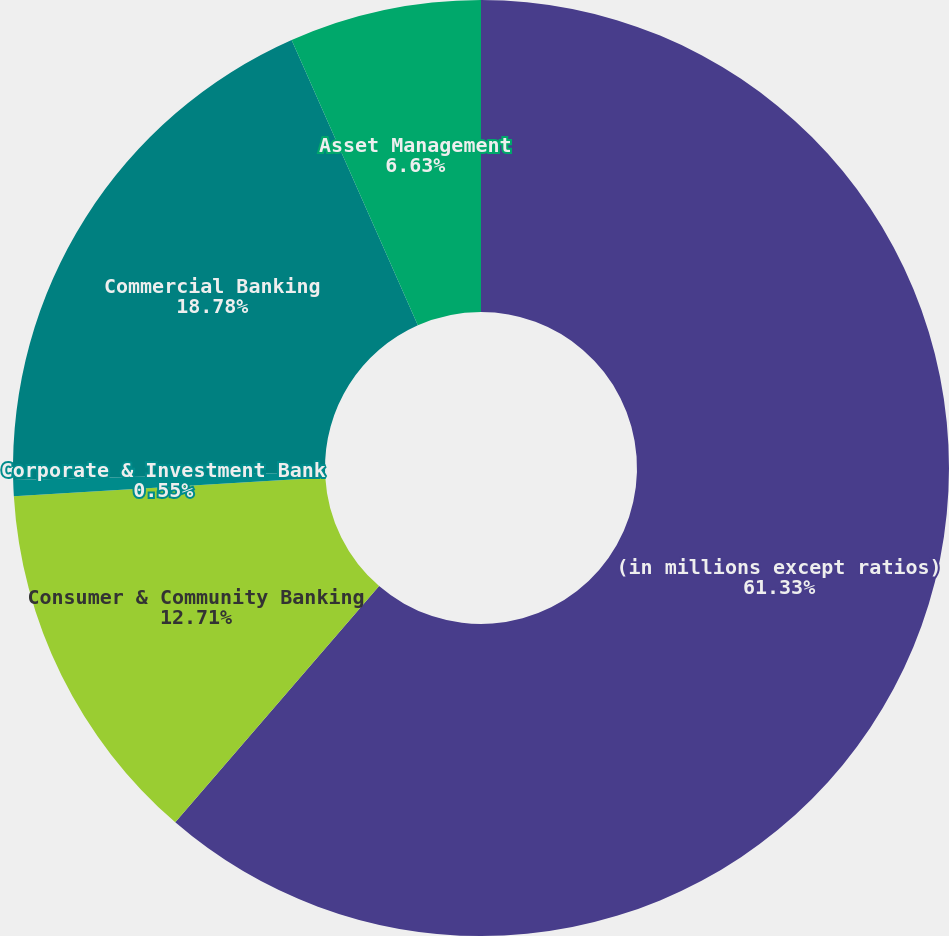<chart> <loc_0><loc_0><loc_500><loc_500><pie_chart><fcel>(in millions except ratios)<fcel>Consumer & Community Banking<fcel>Corporate & Investment Bank<fcel>Commercial Banking<fcel>Asset Management<nl><fcel>61.33%<fcel>12.71%<fcel>0.55%<fcel>18.78%<fcel>6.63%<nl></chart> 